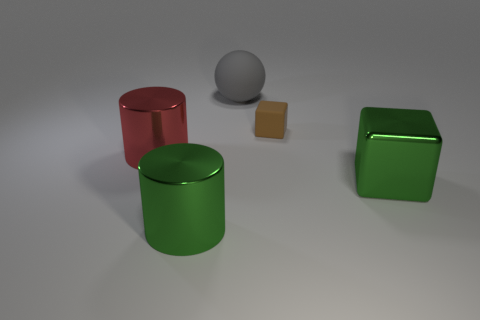Add 4 large gray rubber things. How many objects exist? 9 Subtract all cubes. How many objects are left? 3 Add 1 small brown blocks. How many small brown blocks are left? 2 Add 2 tiny purple shiny blocks. How many tiny purple shiny blocks exist? 2 Subtract 0 brown balls. How many objects are left? 5 Subtract all purple matte things. Subtract all tiny blocks. How many objects are left? 4 